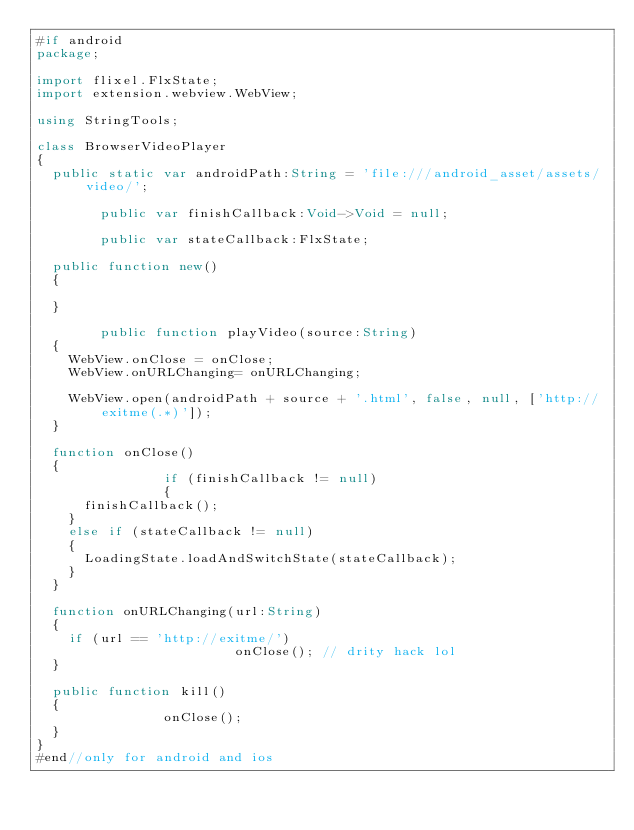<code> <loc_0><loc_0><loc_500><loc_500><_Haxe_>#if android
package;

import flixel.FlxState;
import extension.webview.WebView;

using StringTools;

class BrowserVideoPlayer
{
	public static var androidPath:String = 'file:///android_asset/assets/video/';

        public var finishCallback:Void->Void = null;

        public var stateCallback:FlxState;

	public function new()
	{

	}

        public function playVideo(source:String)
	{
		WebView.onClose = onClose;
		WebView.onURLChanging= onURLChanging;

		WebView.open(androidPath + source + '.html', false, null, ['http://exitme(.*)']);
	}

	function onClose()
	{
                if (finishCallback != null)
                {
			finishCallback();
		}
		else if (stateCallback != null)
		{
			LoadingState.loadAndSwitchState(stateCallback);
		}
	}

	function onURLChanging(url:String) 
	{
		if (url == 'http://exitme/') 
                         onClose(); // drity hack lol
	}

	public function kill()
	{
                onClose();
	}
}
#end//only for android and ios
</code> 